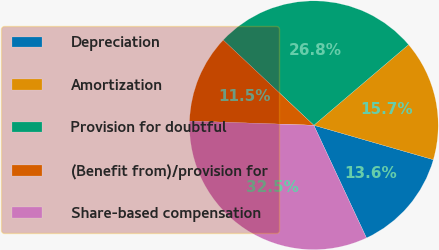Convert chart. <chart><loc_0><loc_0><loc_500><loc_500><pie_chart><fcel>Depreciation<fcel>Amortization<fcel>Provision for doubtful<fcel>(Benefit from)/provision for<fcel>Share-based compensation<nl><fcel>13.58%<fcel>15.68%<fcel>26.77%<fcel>11.47%<fcel>32.5%<nl></chart> 